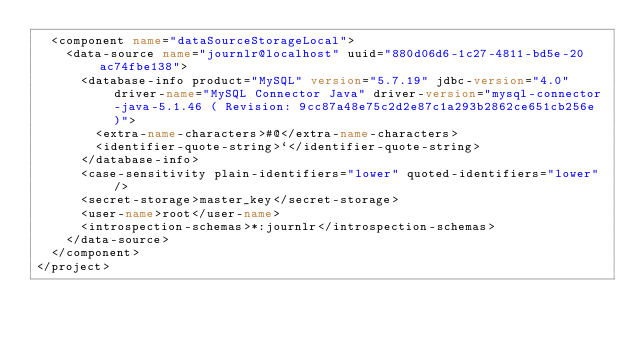<code> <loc_0><loc_0><loc_500><loc_500><_XML_>  <component name="dataSourceStorageLocal">
    <data-source name="journlr@localhost" uuid="880d06d6-1c27-4811-bd5e-20ac74fbe138">
      <database-info product="MySQL" version="5.7.19" jdbc-version="4.0" driver-name="MySQL Connector Java" driver-version="mysql-connector-java-5.1.46 ( Revision: 9cc87a48e75c2d2e87c1a293b2862ce651cb256e )">
        <extra-name-characters>#@</extra-name-characters>
        <identifier-quote-string>`</identifier-quote-string>
      </database-info>
      <case-sensitivity plain-identifiers="lower" quoted-identifiers="lower" />
      <secret-storage>master_key</secret-storage>
      <user-name>root</user-name>
      <introspection-schemas>*:journlr</introspection-schemas>
    </data-source>
  </component>
</project></code> 